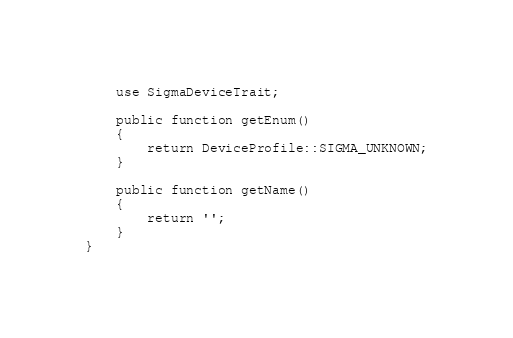<code> <loc_0><loc_0><loc_500><loc_500><_PHP_>    use SigmaDeviceTrait;

    public function getEnum()
    {
        return DeviceProfile::SIGMA_UNKNOWN;
    }

    public function getName()
    {
        return '';
    }
}
</code> 